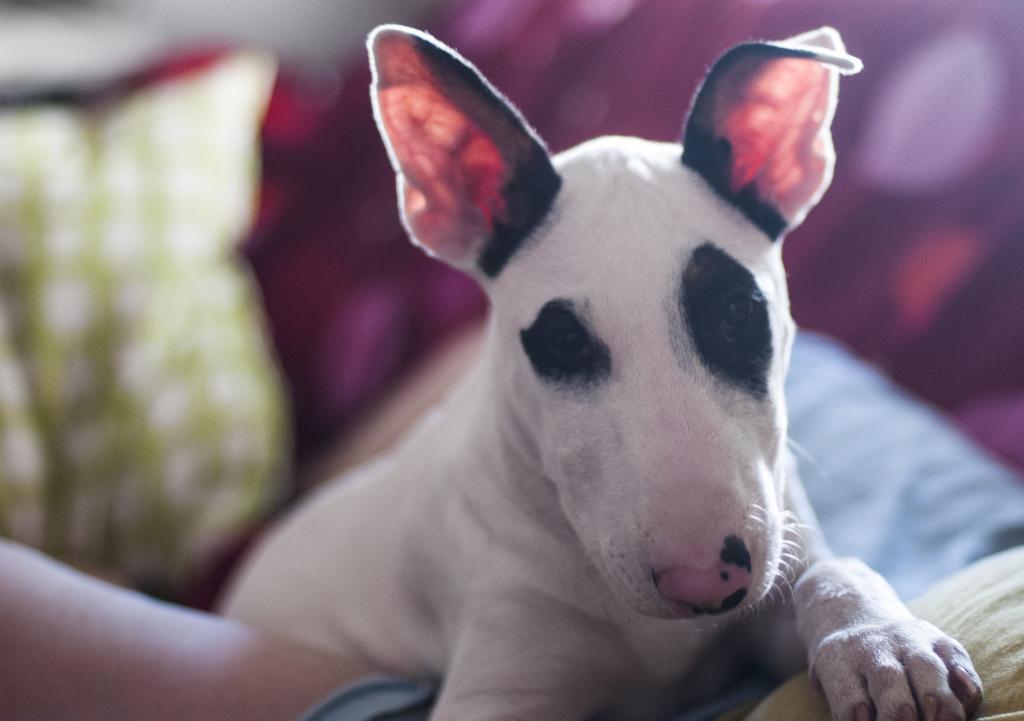Please provide a concise description of this image. In this image I can see a dog on the person's body, behind that there are some pillows. 